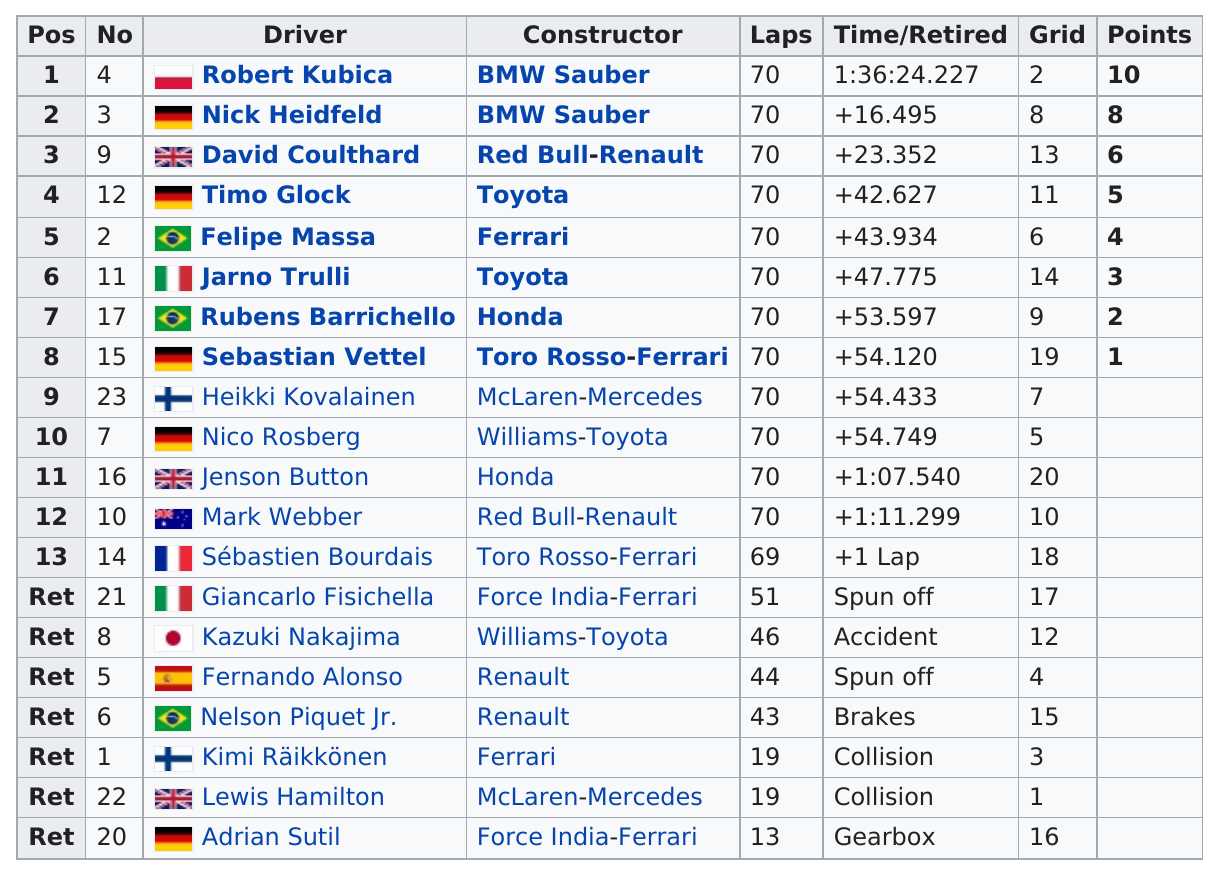Point out several critical features in this image. In the 2008 Canadian Grand Prix, five drivers finished before Jarno Trulli. Adrian Sutil, a retired driver, completed the least amount of laps among all retired drivers. Out of the drivers who completed at least 45 laps, 15 successfully finished the race. Two cars spun off the track during the race. Jenson Button finished after Nico Rosberg, who himself had previously finished after another individual. 